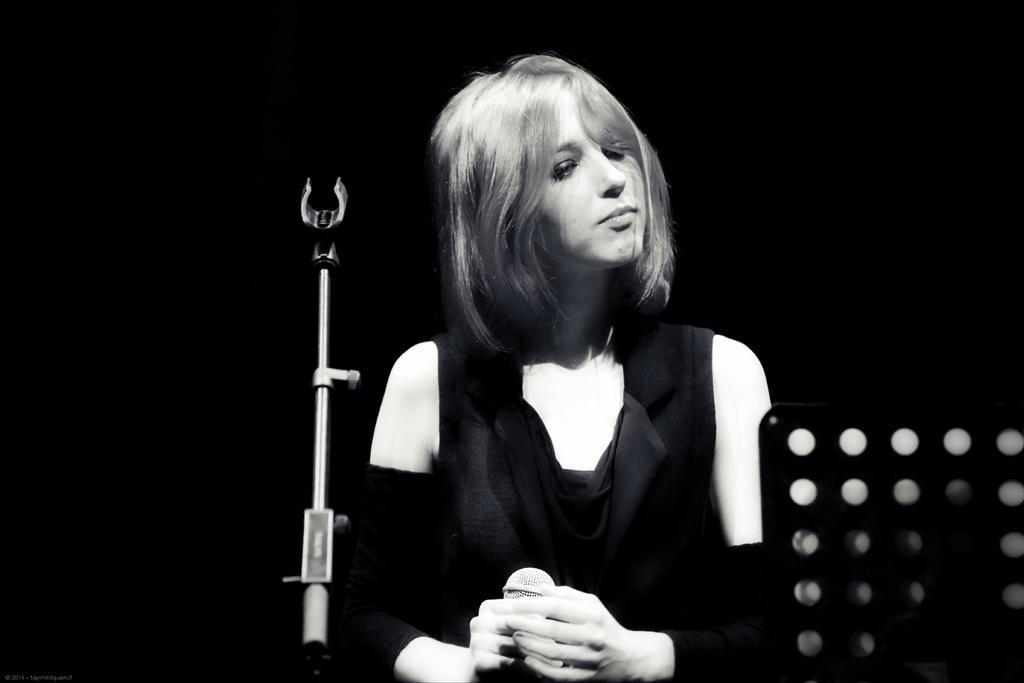Could you give a brief overview of what you see in this image? In this image I can see a woman wearing a black color skirt , in front of him I can see a mike and she holding an object. 